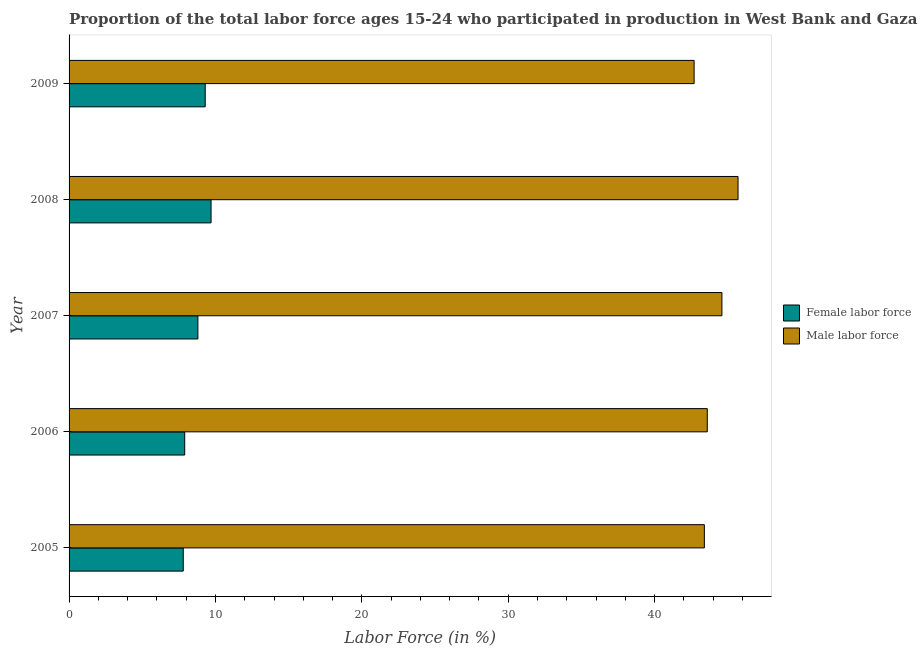How many groups of bars are there?
Offer a terse response. 5. Are the number of bars on each tick of the Y-axis equal?
Provide a succinct answer. Yes. In how many cases, is the number of bars for a given year not equal to the number of legend labels?
Give a very brief answer. 0. What is the percentage of female labor force in 2009?
Your answer should be very brief. 9.3. Across all years, what is the maximum percentage of female labor force?
Your answer should be compact. 9.7. Across all years, what is the minimum percentage of female labor force?
Keep it short and to the point. 7.8. In which year was the percentage of male labour force maximum?
Keep it short and to the point. 2008. What is the total percentage of male labour force in the graph?
Offer a terse response. 220. What is the difference between the percentage of female labor force in 2006 and that in 2009?
Keep it short and to the point. -1.4. What is the difference between the percentage of female labor force in 2008 and the percentage of male labour force in 2007?
Offer a terse response. -34.9. In how many years, is the percentage of female labor force greater than 6 %?
Offer a terse response. 5. What is the ratio of the percentage of male labour force in 2005 to that in 2008?
Your answer should be compact. 0.95. Is the percentage of female labor force in 2007 less than that in 2009?
Provide a succinct answer. Yes. In how many years, is the percentage of male labour force greater than the average percentage of male labour force taken over all years?
Keep it short and to the point. 2. Is the sum of the percentage of male labour force in 2007 and 2008 greater than the maximum percentage of female labor force across all years?
Make the answer very short. Yes. What does the 2nd bar from the top in 2008 represents?
Provide a short and direct response. Female labor force. What does the 1st bar from the bottom in 2008 represents?
Your answer should be compact. Female labor force. Are the values on the major ticks of X-axis written in scientific E-notation?
Provide a succinct answer. No. Does the graph contain grids?
Make the answer very short. No. How many legend labels are there?
Keep it short and to the point. 2. What is the title of the graph?
Offer a very short reply. Proportion of the total labor force ages 15-24 who participated in production in West Bank and Gaza. What is the label or title of the X-axis?
Offer a very short reply. Labor Force (in %). What is the Labor Force (in %) in Female labor force in 2005?
Provide a succinct answer. 7.8. What is the Labor Force (in %) in Male labor force in 2005?
Offer a terse response. 43.4. What is the Labor Force (in %) of Female labor force in 2006?
Your answer should be compact. 7.9. What is the Labor Force (in %) in Male labor force in 2006?
Give a very brief answer. 43.6. What is the Labor Force (in %) in Female labor force in 2007?
Make the answer very short. 8.8. What is the Labor Force (in %) of Male labor force in 2007?
Ensure brevity in your answer.  44.6. What is the Labor Force (in %) in Female labor force in 2008?
Your answer should be very brief. 9.7. What is the Labor Force (in %) of Male labor force in 2008?
Provide a short and direct response. 45.7. What is the Labor Force (in %) in Female labor force in 2009?
Offer a terse response. 9.3. What is the Labor Force (in %) of Male labor force in 2009?
Offer a very short reply. 42.7. Across all years, what is the maximum Labor Force (in %) in Female labor force?
Offer a terse response. 9.7. Across all years, what is the maximum Labor Force (in %) of Male labor force?
Provide a succinct answer. 45.7. Across all years, what is the minimum Labor Force (in %) in Female labor force?
Your answer should be very brief. 7.8. Across all years, what is the minimum Labor Force (in %) in Male labor force?
Offer a very short reply. 42.7. What is the total Labor Force (in %) in Female labor force in the graph?
Provide a succinct answer. 43.5. What is the total Labor Force (in %) in Male labor force in the graph?
Give a very brief answer. 220. What is the difference between the Labor Force (in %) of Female labor force in 2005 and that in 2006?
Make the answer very short. -0.1. What is the difference between the Labor Force (in %) in Female labor force in 2005 and that in 2008?
Your answer should be compact. -1.9. What is the difference between the Labor Force (in %) in Male labor force in 2005 and that in 2008?
Offer a terse response. -2.3. What is the difference between the Labor Force (in %) in Female labor force in 2005 and that in 2009?
Make the answer very short. -1.5. What is the difference between the Labor Force (in %) of Male labor force in 2005 and that in 2009?
Your answer should be compact. 0.7. What is the difference between the Labor Force (in %) of Female labor force in 2006 and that in 2007?
Offer a very short reply. -0.9. What is the difference between the Labor Force (in %) in Male labor force in 2006 and that in 2008?
Provide a short and direct response. -2.1. What is the difference between the Labor Force (in %) of Female labor force in 2006 and that in 2009?
Give a very brief answer. -1.4. What is the difference between the Labor Force (in %) of Male labor force in 2006 and that in 2009?
Make the answer very short. 0.9. What is the difference between the Labor Force (in %) in Female labor force in 2007 and that in 2008?
Your response must be concise. -0.9. What is the difference between the Labor Force (in %) in Male labor force in 2007 and that in 2008?
Your answer should be compact. -1.1. What is the difference between the Labor Force (in %) of Male labor force in 2007 and that in 2009?
Ensure brevity in your answer.  1.9. What is the difference between the Labor Force (in %) in Male labor force in 2008 and that in 2009?
Provide a short and direct response. 3. What is the difference between the Labor Force (in %) of Female labor force in 2005 and the Labor Force (in %) of Male labor force in 2006?
Provide a short and direct response. -35.8. What is the difference between the Labor Force (in %) of Female labor force in 2005 and the Labor Force (in %) of Male labor force in 2007?
Provide a succinct answer. -36.8. What is the difference between the Labor Force (in %) in Female labor force in 2005 and the Labor Force (in %) in Male labor force in 2008?
Make the answer very short. -37.9. What is the difference between the Labor Force (in %) in Female labor force in 2005 and the Labor Force (in %) in Male labor force in 2009?
Offer a very short reply. -34.9. What is the difference between the Labor Force (in %) in Female labor force in 2006 and the Labor Force (in %) in Male labor force in 2007?
Offer a very short reply. -36.7. What is the difference between the Labor Force (in %) of Female labor force in 2006 and the Labor Force (in %) of Male labor force in 2008?
Offer a very short reply. -37.8. What is the difference between the Labor Force (in %) in Female labor force in 2006 and the Labor Force (in %) in Male labor force in 2009?
Your answer should be very brief. -34.8. What is the difference between the Labor Force (in %) of Female labor force in 2007 and the Labor Force (in %) of Male labor force in 2008?
Give a very brief answer. -36.9. What is the difference between the Labor Force (in %) of Female labor force in 2007 and the Labor Force (in %) of Male labor force in 2009?
Make the answer very short. -33.9. What is the difference between the Labor Force (in %) in Female labor force in 2008 and the Labor Force (in %) in Male labor force in 2009?
Your response must be concise. -33. What is the average Labor Force (in %) of Female labor force per year?
Make the answer very short. 8.7. What is the average Labor Force (in %) of Male labor force per year?
Offer a very short reply. 44. In the year 2005, what is the difference between the Labor Force (in %) of Female labor force and Labor Force (in %) of Male labor force?
Your answer should be very brief. -35.6. In the year 2006, what is the difference between the Labor Force (in %) in Female labor force and Labor Force (in %) in Male labor force?
Provide a short and direct response. -35.7. In the year 2007, what is the difference between the Labor Force (in %) in Female labor force and Labor Force (in %) in Male labor force?
Ensure brevity in your answer.  -35.8. In the year 2008, what is the difference between the Labor Force (in %) in Female labor force and Labor Force (in %) in Male labor force?
Provide a short and direct response. -36. In the year 2009, what is the difference between the Labor Force (in %) of Female labor force and Labor Force (in %) of Male labor force?
Offer a terse response. -33.4. What is the ratio of the Labor Force (in %) of Female labor force in 2005 to that in 2006?
Keep it short and to the point. 0.99. What is the ratio of the Labor Force (in %) of Male labor force in 2005 to that in 2006?
Keep it short and to the point. 1. What is the ratio of the Labor Force (in %) in Female labor force in 2005 to that in 2007?
Ensure brevity in your answer.  0.89. What is the ratio of the Labor Force (in %) in Male labor force in 2005 to that in 2007?
Provide a short and direct response. 0.97. What is the ratio of the Labor Force (in %) in Female labor force in 2005 to that in 2008?
Your response must be concise. 0.8. What is the ratio of the Labor Force (in %) in Male labor force in 2005 to that in 2008?
Your response must be concise. 0.95. What is the ratio of the Labor Force (in %) in Female labor force in 2005 to that in 2009?
Ensure brevity in your answer.  0.84. What is the ratio of the Labor Force (in %) of Male labor force in 2005 to that in 2009?
Your answer should be compact. 1.02. What is the ratio of the Labor Force (in %) in Female labor force in 2006 to that in 2007?
Ensure brevity in your answer.  0.9. What is the ratio of the Labor Force (in %) in Male labor force in 2006 to that in 2007?
Your response must be concise. 0.98. What is the ratio of the Labor Force (in %) in Female labor force in 2006 to that in 2008?
Your answer should be compact. 0.81. What is the ratio of the Labor Force (in %) in Male labor force in 2006 to that in 2008?
Keep it short and to the point. 0.95. What is the ratio of the Labor Force (in %) in Female labor force in 2006 to that in 2009?
Make the answer very short. 0.85. What is the ratio of the Labor Force (in %) of Male labor force in 2006 to that in 2009?
Your answer should be very brief. 1.02. What is the ratio of the Labor Force (in %) of Female labor force in 2007 to that in 2008?
Provide a succinct answer. 0.91. What is the ratio of the Labor Force (in %) of Male labor force in 2007 to that in 2008?
Offer a very short reply. 0.98. What is the ratio of the Labor Force (in %) in Female labor force in 2007 to that in 2009?
Your answer should be compact. 0.95. What is the ratio of the Labor Force (in %) in Male labor force in 2007 to that in 2009?
Your answer should be compact. 1.04. What is the ratio of the Labor Force (in %) of Female labor force in 2008 to that in 2009?
Your answer should be very brief. 1.04. What is the ratio of the Labor Force (in %) of Male labor force in 2008 to that in 2009?
Give a very brief answer. 1.07. What is the difference between the highest and the lowest Labor Force (in %) in Female labor force?
Provide a short and direct response. 1.9. 